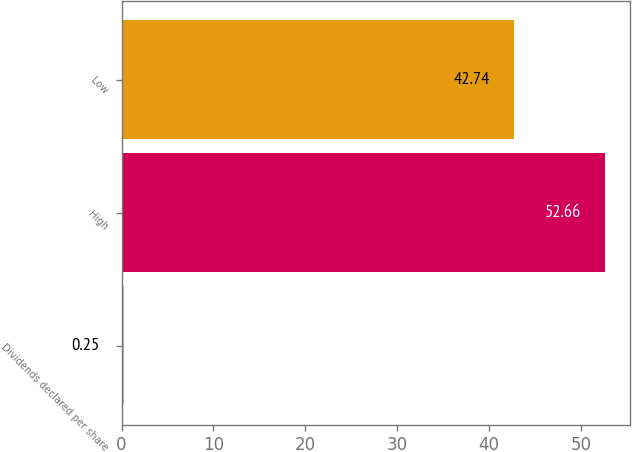<chart> <loc_0><loc_0><loc_500><loc_500><bar_chart><fcel>Dividends declared per share<fcel>High<fcel>Low<nl><fcel>0.25<fcel>52.66<fcel>42.74<nl></chart> 